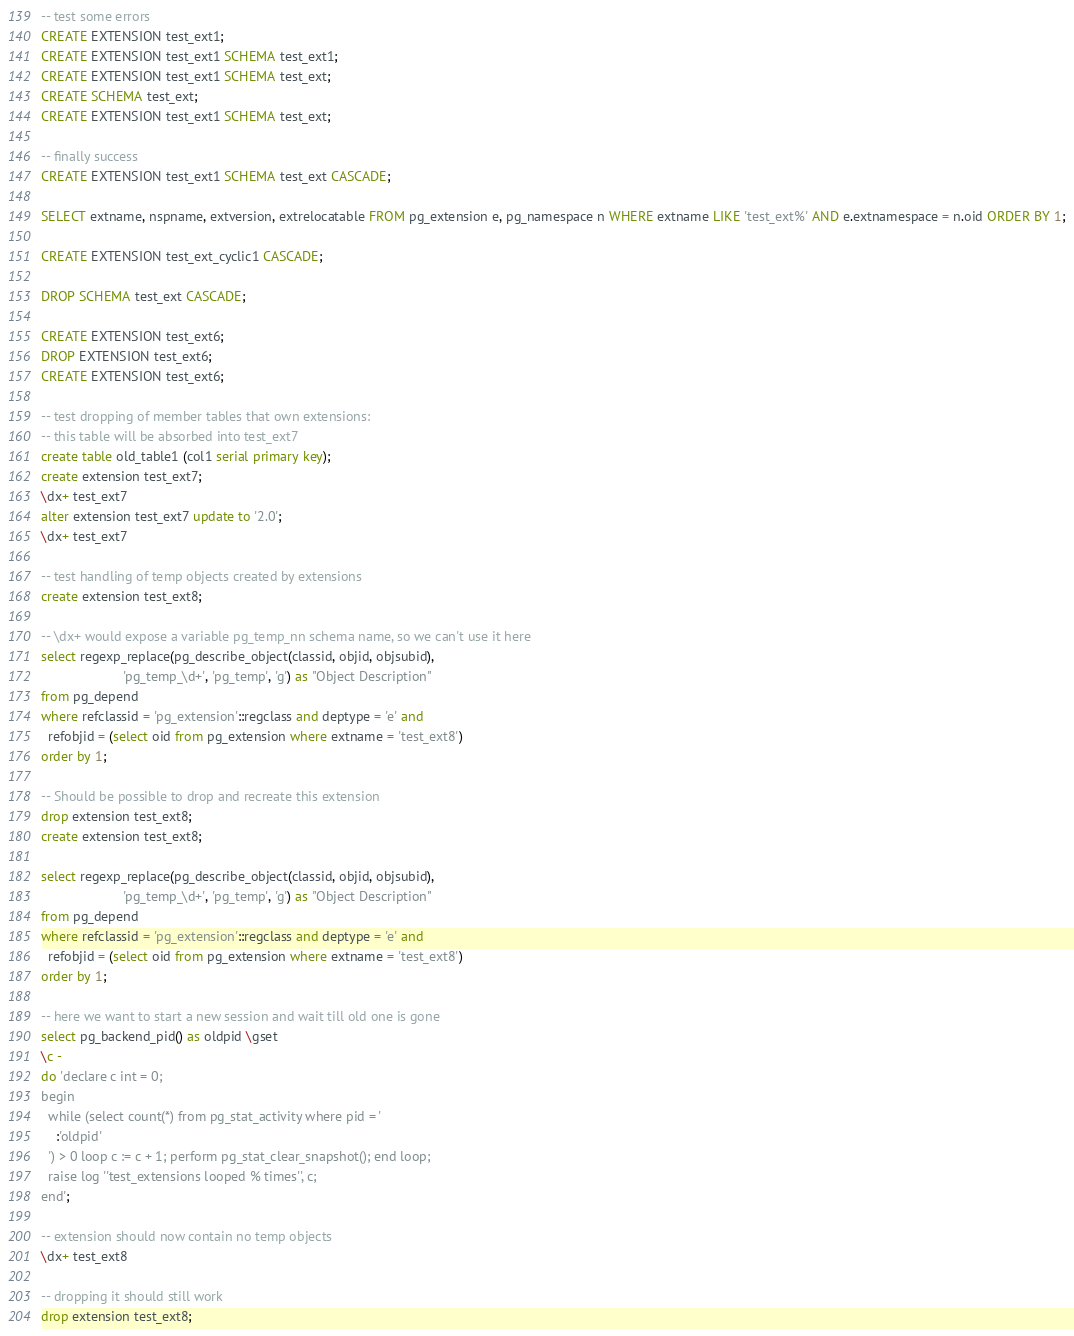Convert code to text. <code><loc_0><loc_0><loc_500><loc_500><_SQL_>-- test some errors
CREATE EXTENSION test_ext1;
CREATE EXTENSION test_ext1 SCHEMA test_ext1;
CREATE EXTENSION test_ext1 SCHEMA test_ext;
CREATE SCHEMA test_ext;
CREATE EXTENSION test_ext1 SCHEMA test_ext;

-- finally success
CREATE EXTENSION test_ext1 SCHEMA test_ext CASCADE;

SELECT extname, nspname, extversion, extrelocatable FROM pg_extension e, pg_namespace n WHERE extname LIKE 'test_ext%' AND e.extnamespace = n.oid ORDER BY 1;

CREATE EXTENSION test_ext_cyclic1 CASCADE;

DROP SCHEMA test_ext CASCADE;

CREATE EXTENSION test_ext6;
DROP EXTENSION test_ext6;
CREATE EXTENSION test_ext6;

-- test dropping of member tables that own extensions:
-- this table will be absorbed into test_ext7
create table old_table1 (col1 serial primary key);
create extension test_ext7;
\dx+ test_ext7
alter extension test_ext7 update to '2.0';
\dx+ test_ext7

-- test handling of temp objects created by extensions
create extension test_ext8;

-- \dx+ would expose a variable pg_temp_nn schema name, so we can't use it here
select regexp_replace(pg_describe_object(classid, objid, objsubid),
                      'pg_temp_\d+', 'pg_temp', 'g') as "Object Description"
from pg_depend
where refclassid = 'pg_extension'::regclass and deptype = 'e' and
  refobjid = (select oid from pg_extension where extname = 'test_ext8')
order by 1;

-- Should be possible to drop and recreate this extension
drop extension test_ext8;
create extension test_ext8;

select regexp_replace(pg_describe_object(classid, objid, objsubid),
                      'pg_temp_\d+', 'pg_temp', 'g') as "Object Description"
from pg_depend
where refclassid = 'pg_extension'::regclass and deptype = 'e' and
  refobjid = (select oid from pg_extension where extname = 'test_ext8')
order by 1;

-- here we want to start a new session and wait till old one is gone
select pg_backend_pid() as oldpid \gset
\c -
do 'declare c int = 0;
begin
  while (select count(*) from pg_stat_activity where pid = '
    :'oldpid'
  ') > 0 loop c := c + 1; perform pg_stat_clear_snapshot(); end loop;
  raise log ''test_extensions looped % times'', c;
end';

-- extension should now contain no temp objects
\dx+ test_ext8

-- dropping it should still work
drop extension test_ext8;
</code> 